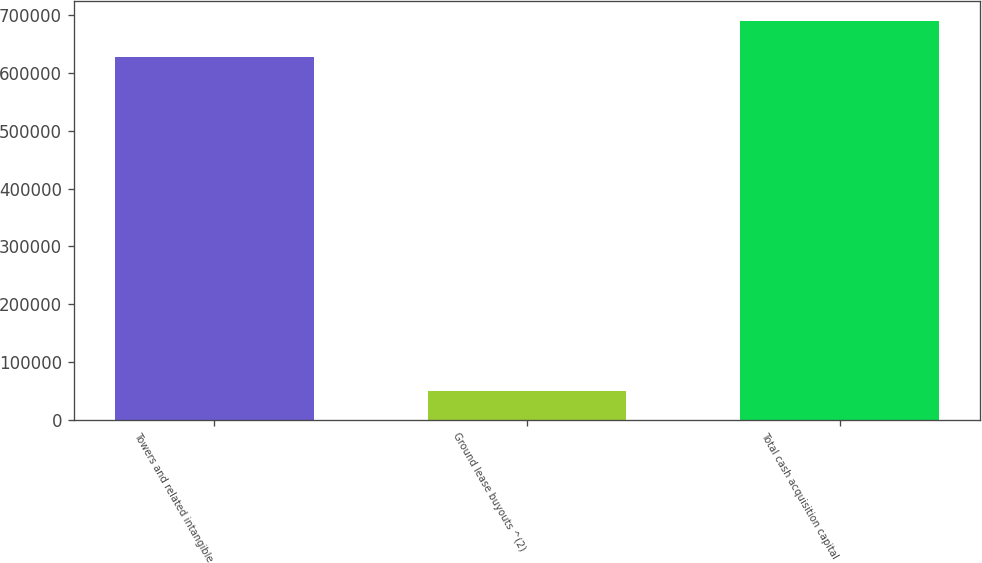Convert chart to OTSL. <chart><loc_0><loc_0><loc_500><loc_500><bar_chart><fcel>Towers and related intangible<fcel>Ground lease buyouts ^(2)<fcel>Total cash acquisition capital<nl><fcel>628423<fcel>48956<fcel>691265<nl></chart> 